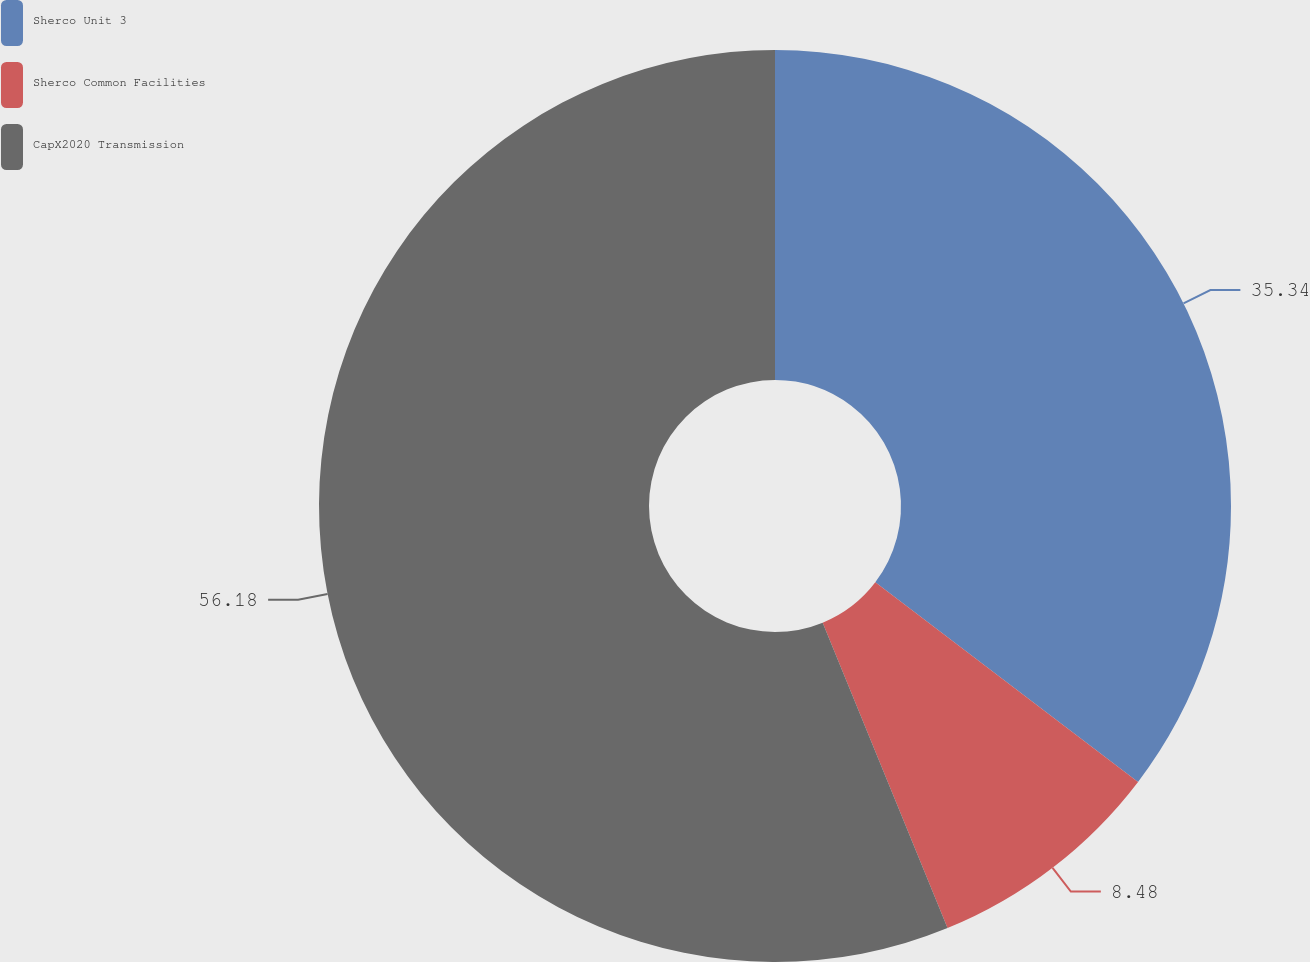Convert chart to OTSL. <chart><loc_0><loc_0><loc_500><loc_500><pie_chart><fcel>Sherco Unit 3<fcel>Sherco Common Facilities<fcel>CapX2020 Transmission<nl><fcel>35.34%<fcel>8.48%<fcel>56.17%<nl></chart> 